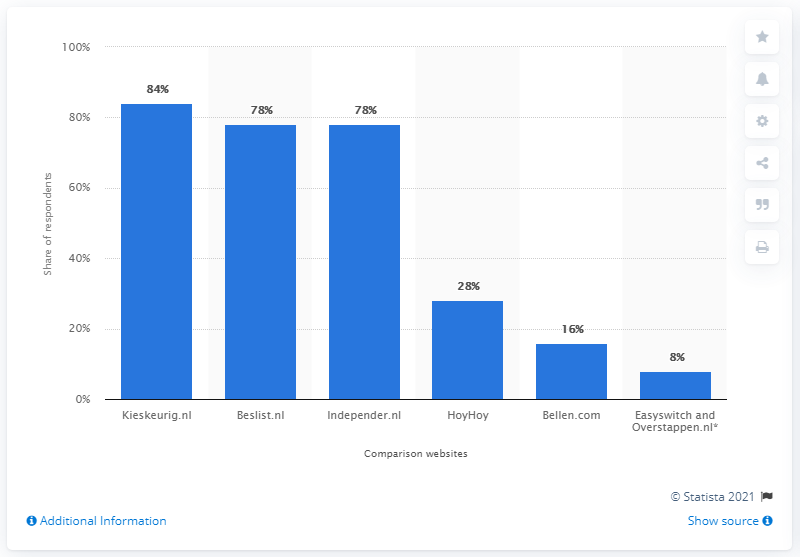Highlight a few significant elements in this photo. In the Netherlands, Kieskeurig.nl was the most well-known price comparison website. 